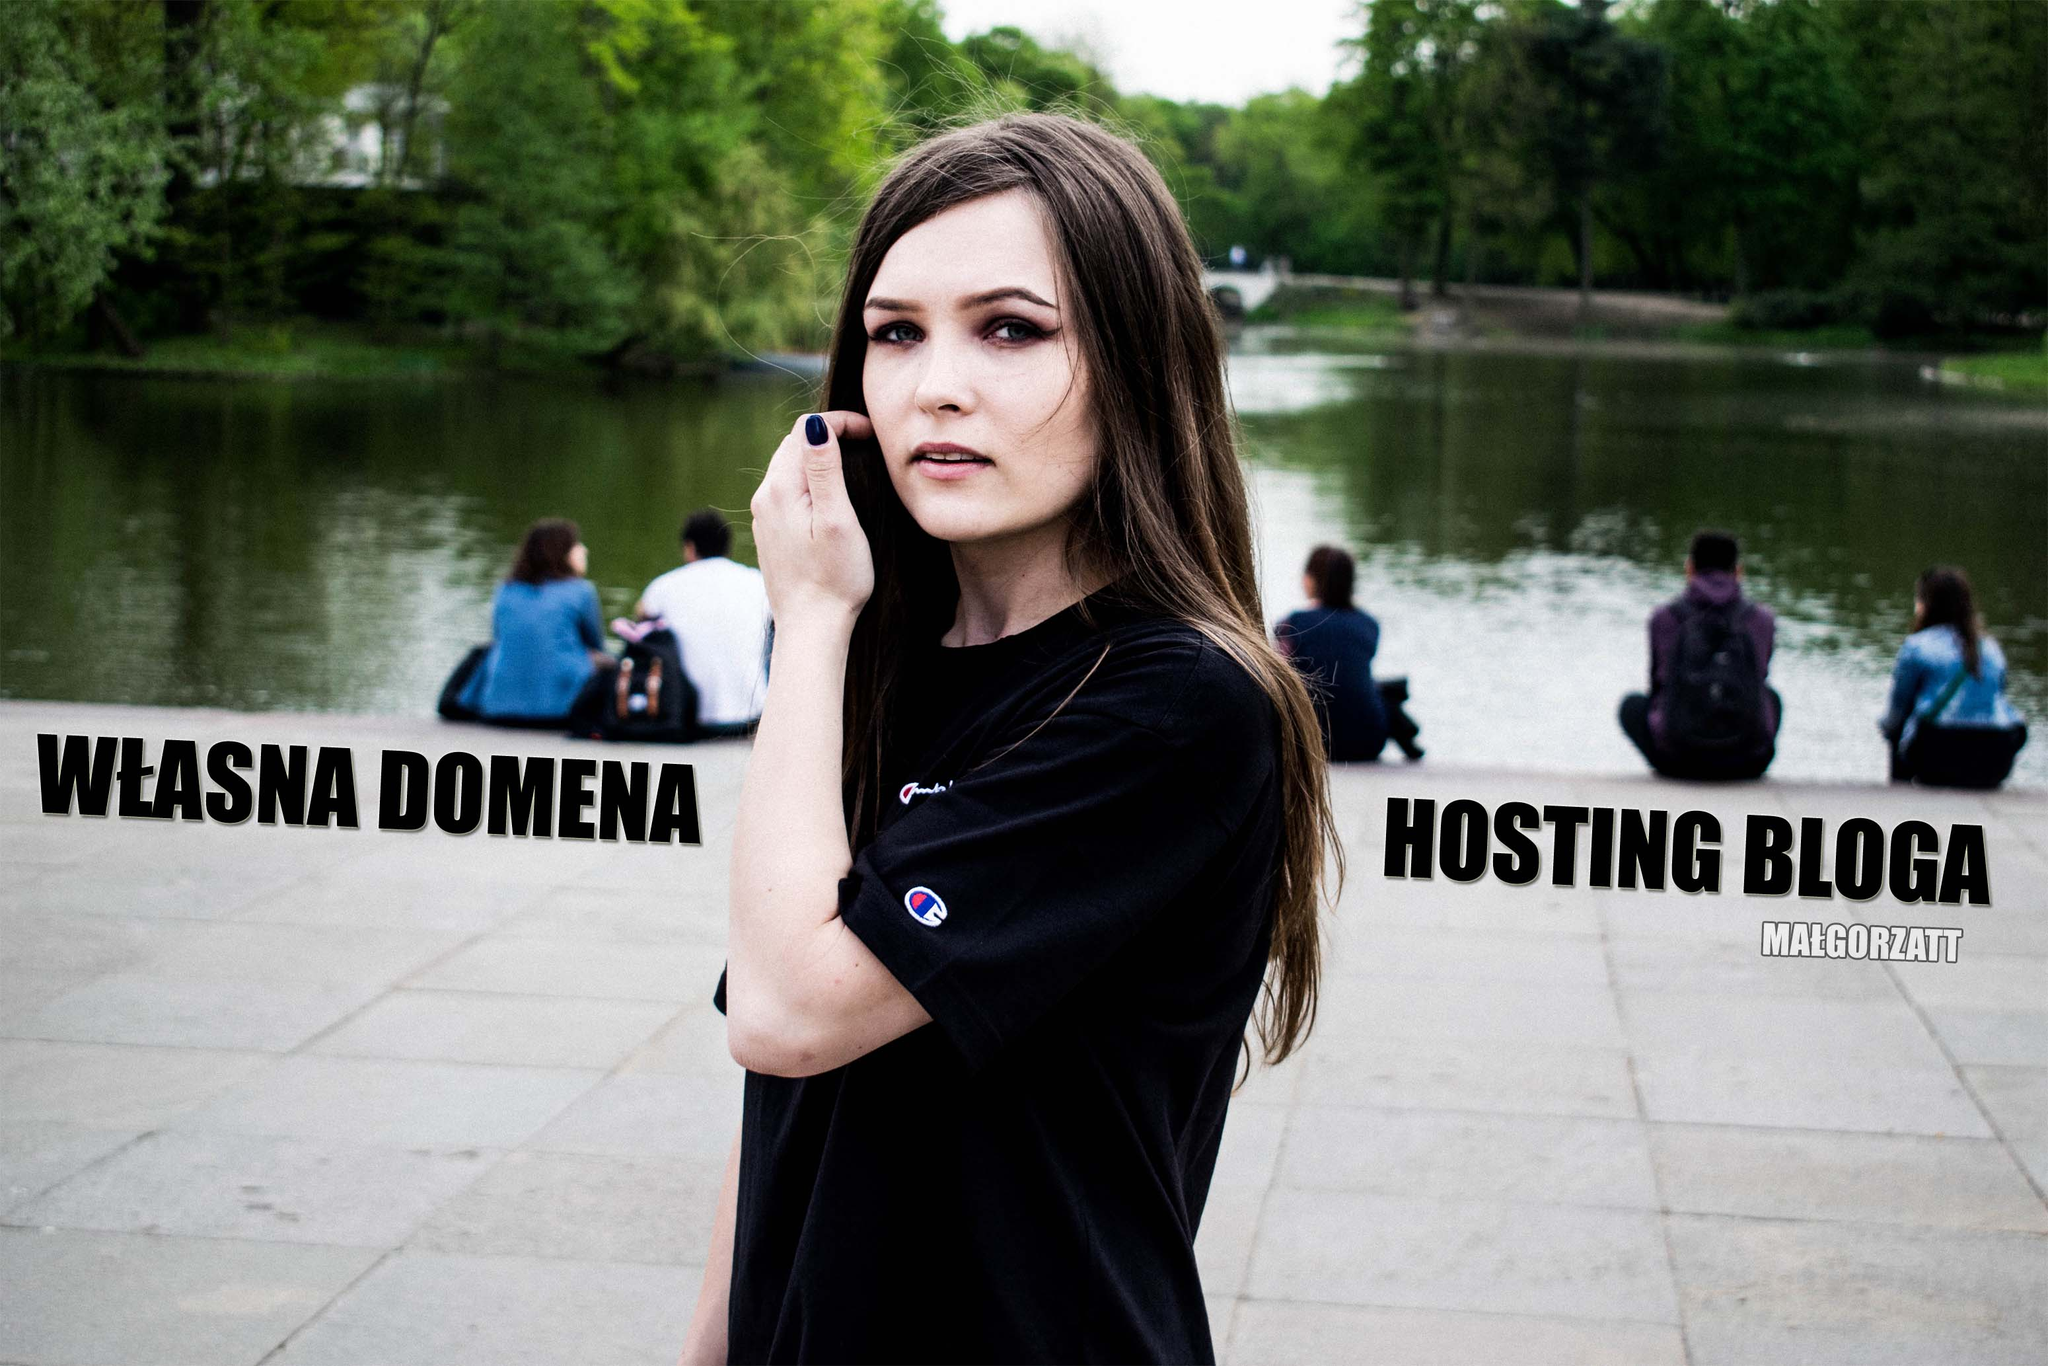Can you provide a concise description of how this image might be used in a marketing context? This image could be used in digital advertisements to promote a web hosting service. Featuring the woman in a casual, serene setting makes the concept of website management feel approachable and accessible. The text 'WŁASNA DOMENA' and 'HOSTING BLOGA' highlight key services, helping to draw attention and inform potential customers about the core offerings of the company. 